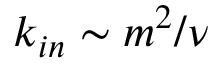<formula> <loc_0><loc_0><loc_500><loc_500>k _ { i n } \sim m ^ { 2 } / \nu</formula> 